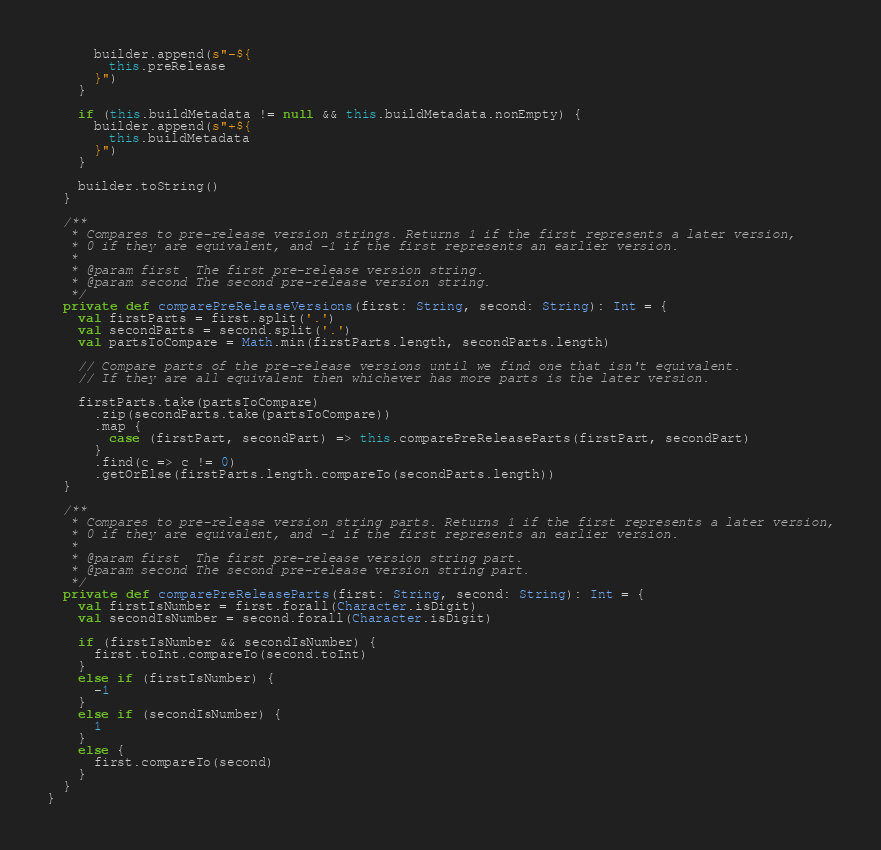Convert code to text. <code><loc_0><loc_0><loc_500><loc_500><_Scala_>      builder.append(s"-${
        this.preRelease
      }")
    }

    if (this.buildMetadata != null && this.buildMetadata.nonEmpty) {
      builder.append(s"+${
        this.buildMetadata
      }")
    }

    builder.toString()
  }

  /**
   * Compares to pre-release version strings. Returns 1 if the first represents a later version,
   * 0 if they are equivalent, and -1 if the first represents an earlier version.
   *
   * @param first  The first pre-release version string.
   * @param second The second pre-release version string.
   */
  private def comparePreReleaseVersions(first: String, second: String): Int = {
    val firstParts = first.split('.')
    val secondParts = second.split('.')
    val partsToCompare = Math.min(firstParts.length, secondParts.length)

    // Compare parts of the pre-release versions until we find one that isn't equivalent.
    // If they are all equivalent then whichever has more parts is the later version.

    firstParts.take(partsToCompare)
      .zip(secondParts.take(partsToCompare))
      .map {
        case (firstPart, secondPart) => this.comparePreReleaseParts(firstPart, secondPart)
      }
      .find(c => c != 0)
      .getOrElse(firstParts.length.compareTo(secondParts.length))
  }

  /**
   * Compares to pre-release version string parts. Returns 1 if the first represents a later version,
   * 0 if they are equivalent, and -1 if the first represents an earlier version.
   *
   * @param first  The first pre-release version string part.
   * @param second The second pre-release version string part.
   */
  private def comparePreReleaseParts(first: String, second: String): Int = {
    val firstIsNumber = first.forall(Character.isDigit)
    val secondIsNumber = second.forall(Character.isDigit)

    if (firstIsNumber && secondIsNumber) {
      first.toInt.compareTo(second.toInt)
    }
    else if (firstIsNumber) {
      -1
    }
    else if (secondIsNumber) {
      1
    }
    else {
      first.compareTo(second)
    }
  }
}
</code> 